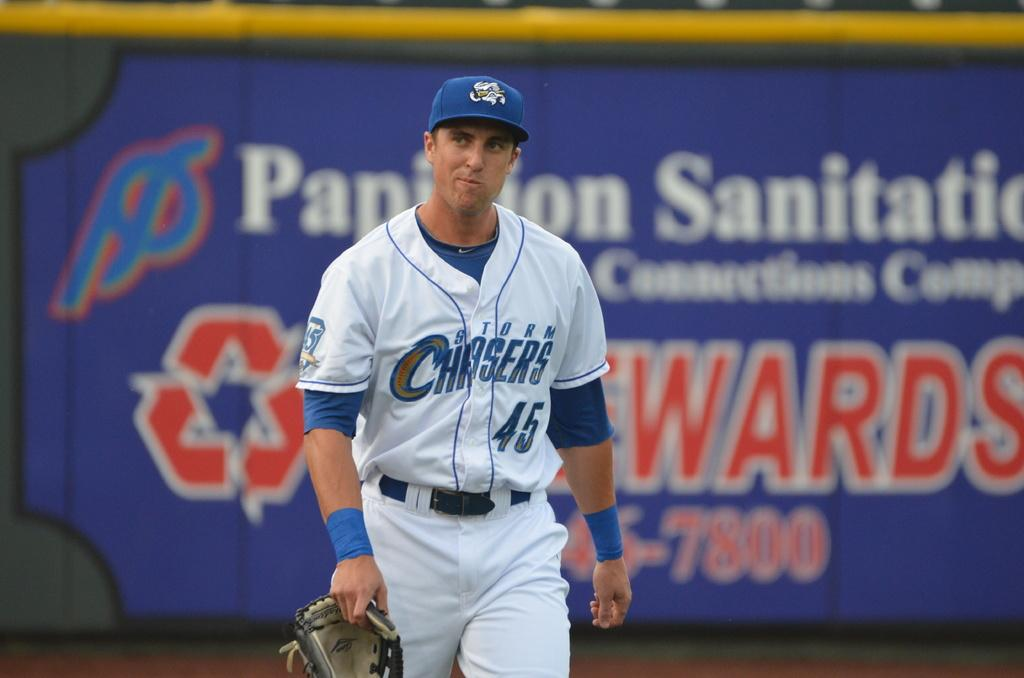<image>
Render a clear and concise summary of the photo. One of the Omaha Storm Chasers baseball players holding a glove with a banner in the background that has an ad for Papillion Sanitation 